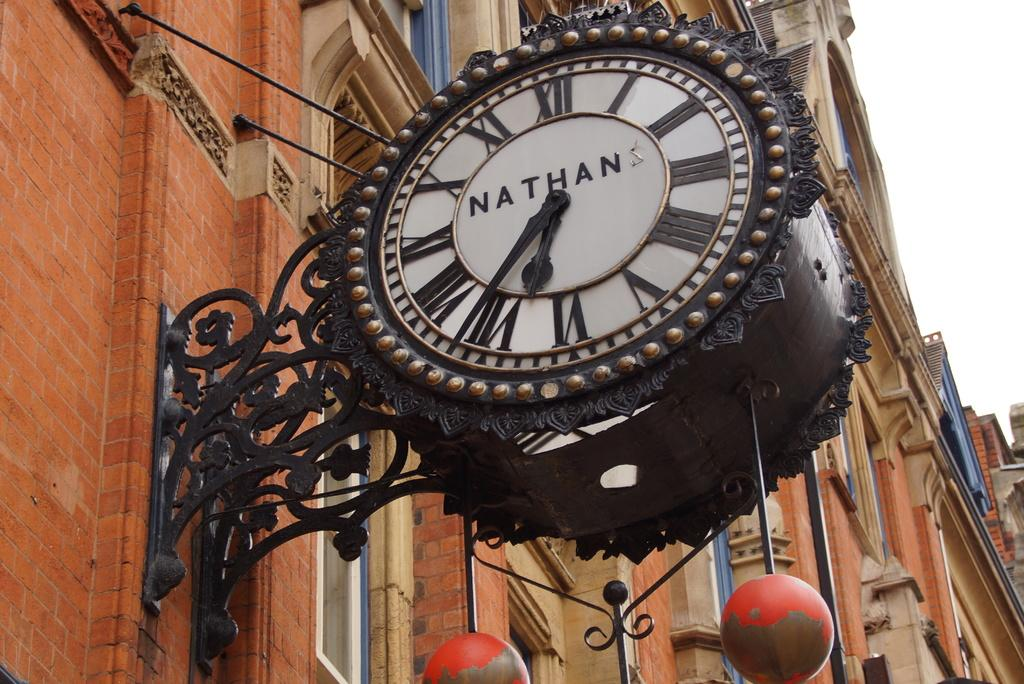<image>
Summarize the visual content of the image. Circule clock hanging outdoors and says NATHAN on the face. 